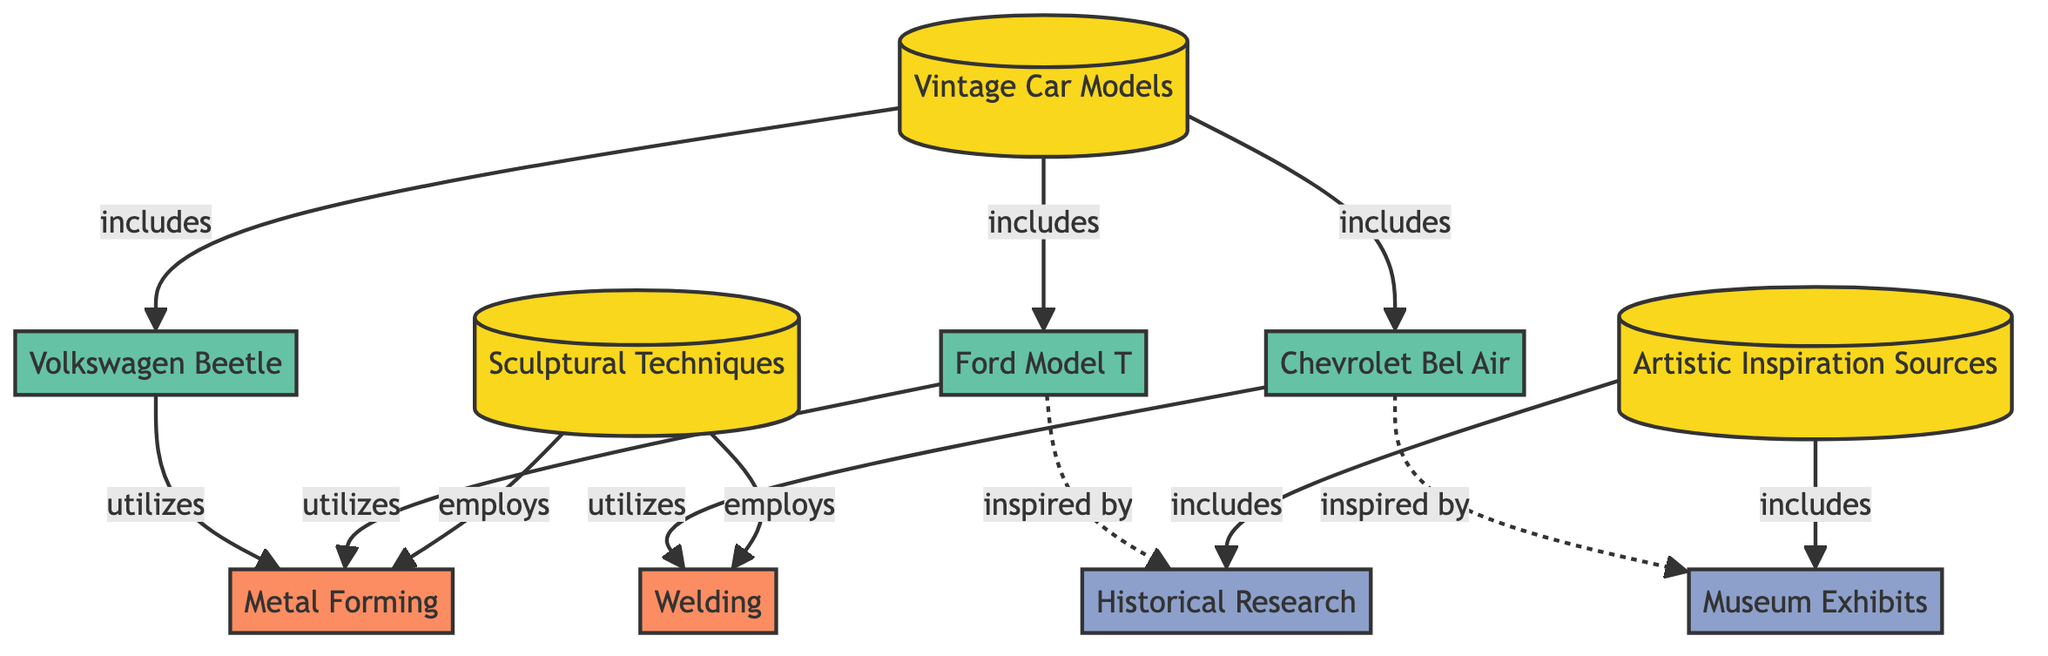What are the three vintage car models included in the diagram? The diagram lists three car models: Ford Model T, Chevrolet Bel Air, and Volkswagen Beetle, all connected to the 'Vintage Car Models' node through 'includes' relationships.
Answer: Ford Model T, Chevrolet Bel Air, Volkswagen Beetle How many techniques are employed in sculptural techniques? The diagram shows two techniques: Metal Forming and Welding, both of which are linked to the 'Sculptural Techniques' node through 'employs' relationships, indicating they are utilized in sculptural practices.
Answer: 2 Which car model utilizes welding as a technique? The diagram indicates that the Chevrolet Bel Air is connected to the Welding node through a 'utilizes' relationship, identifying it as the car model that employs this technique.
Answer: Chevrolet Bel Air What inspired the Ford Model T according to the diagram? The Ford Model T is linked to the Historical Research node through an 'inspired by' relationship, indicating that historical research is a source of inspiration for this vintage model.
Answer: Historical Research How many nodes represent artistic inspiration sources? The diagram presents two artistic inspiration sources: Historical Research and Museum Exhibits, both associated with the 'Artistic Inspiration Sources' category node.
Answer: 2 What is the relationship between the Volkswagen Beetle and Metal Forming? The Volkswagen Beetle node is connected to the Metal Forming node with a 'utilizes' relationship, which signifies that this car model employs metal forming as a sculptural technique.
Answer: utilizes Which two categories are represented in the diagram? The diagram contains three main categories: Vintage Car Models, Sculptural Techniques, and Artistic Inspiration Sources. These categories encapsulate various related nodes beneath them.
Answer: Vintage Car Models, Sculptural Techniques, Artistic Inspiration Sources How many edges are there in total within the diagram? The diagram consists of a total of 11 edges, which represent the various relationships connecting nodes, including includes, employs, and inspired by connections between different categories, models, techniques, and inspirations.
Answer: 11 